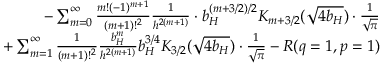Convert formula to latex. <formula><loc_0><loc_0><loc_500><loc_500>\begin{array} { r l r } & { - \sum _ { m = 0 } ^ { \infty } { \frac { m ! ( - 1 ) ^ { m + 1 } } { ( m + 1 ) ! ^ { 2 } } } { \frac { 1 } { h ^ { 2 ( m + 1 ) } } } \cdot b _ { H } ^ { ( m + 3 / 2 ) / 2 } K _ { m + 3 / 2 } ( \sqrt { 4 b _ { H } } ) \cdot { \frac { 1 } { \sqrt { \pi } } } } \\ & { + \sum _ { m = 1 } ^ { \infty } { \frac { 1 } { ( m + 1 ) ! ^ { 2 } } } { \frac { b _ { H } ^ { m } } { h ^ { 2 ( m + 1 ) } } } b _ { H } ^ { 3 / 4 } K _ { 3 / 2 } ( \sqrt { 4 b _ { H } } ) \cdot { \frac { 1 } { \sqrt { \pi } } } - R ( q = 1 , p = 1 ) } \end{array}</formula> 